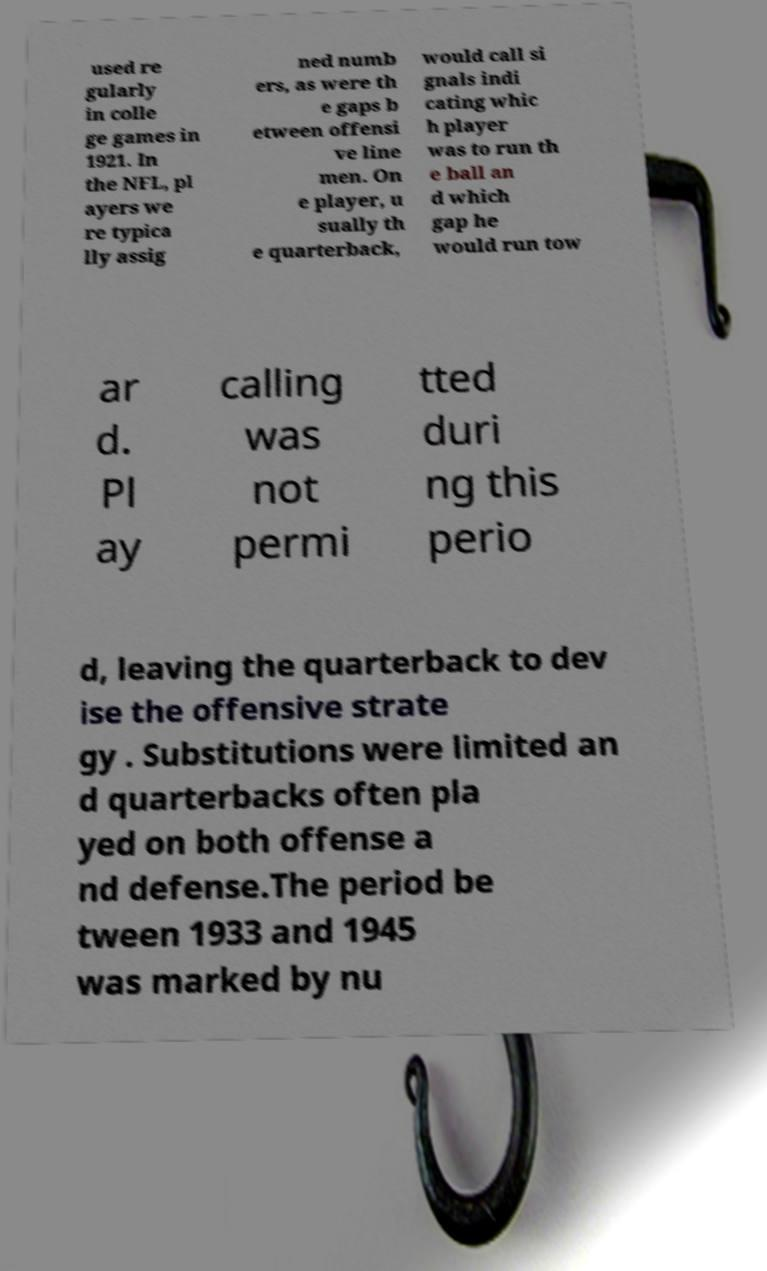What messages or text are displayed in this image? I need them in a readable, typed format. used re gularly in colle ge games in 1921. In the NFL, pl ayers we re typica lly assig ned numb ers, as were th e gaps b etween offensi ve line men. On e player, u sually th e quarterback, would call si gnals indi cating whic h player was to run th e ball an d which gap he would run tow ar d. Pl ay calling was not permi tted duri ng this perio d, leaving the quarterback to dev ise the offensive strate gy . Substitutions were limited an d quarterbacks often pla yed on both offense a nd defense.The period be tween 1933 and 1945 was marked by nu 